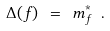Convert formula to latex. <formula><loc_0><loc_0><loc_500><loc_500>\Delta ( f ) \ = \ m _ { f } ^ { * } \ .</formula> 